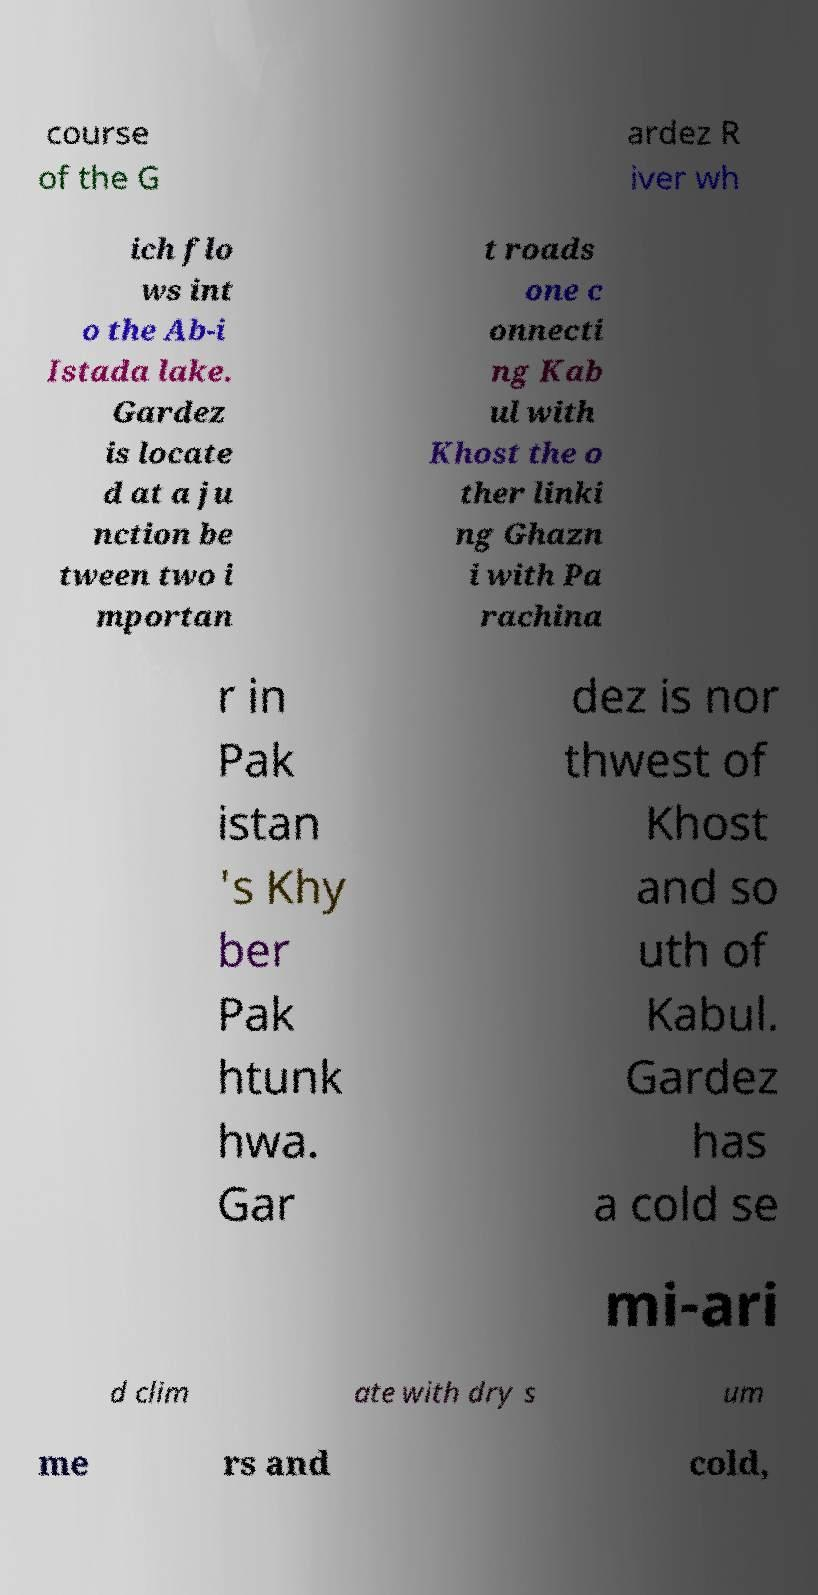I need the written content from this picture converted into text. Can you do that? course of the G ardez R iver wh ich flo ws int o the Ab-i Istada lake. Gardez is locate d at a ju nction be tween two i mportan t roads one c onnecti ng Kab ul with Khost the o ther linki ng Ghazn i with Pa rachina r in Pak istan 's Khy ber Pak htunk hwa. Gar dez is nor thwest of Khost and so uth of Kabul. Gardez has a cold se mi-ari d clim ate with dry s um me rs and cold, 